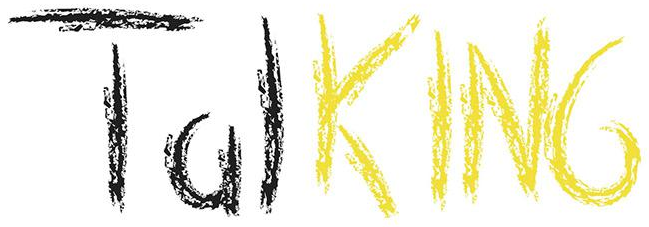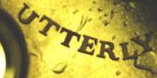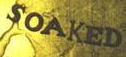Read the text from these images in sequence, separated by a semicolon. TalKING; UTTERLY; SOAKED 